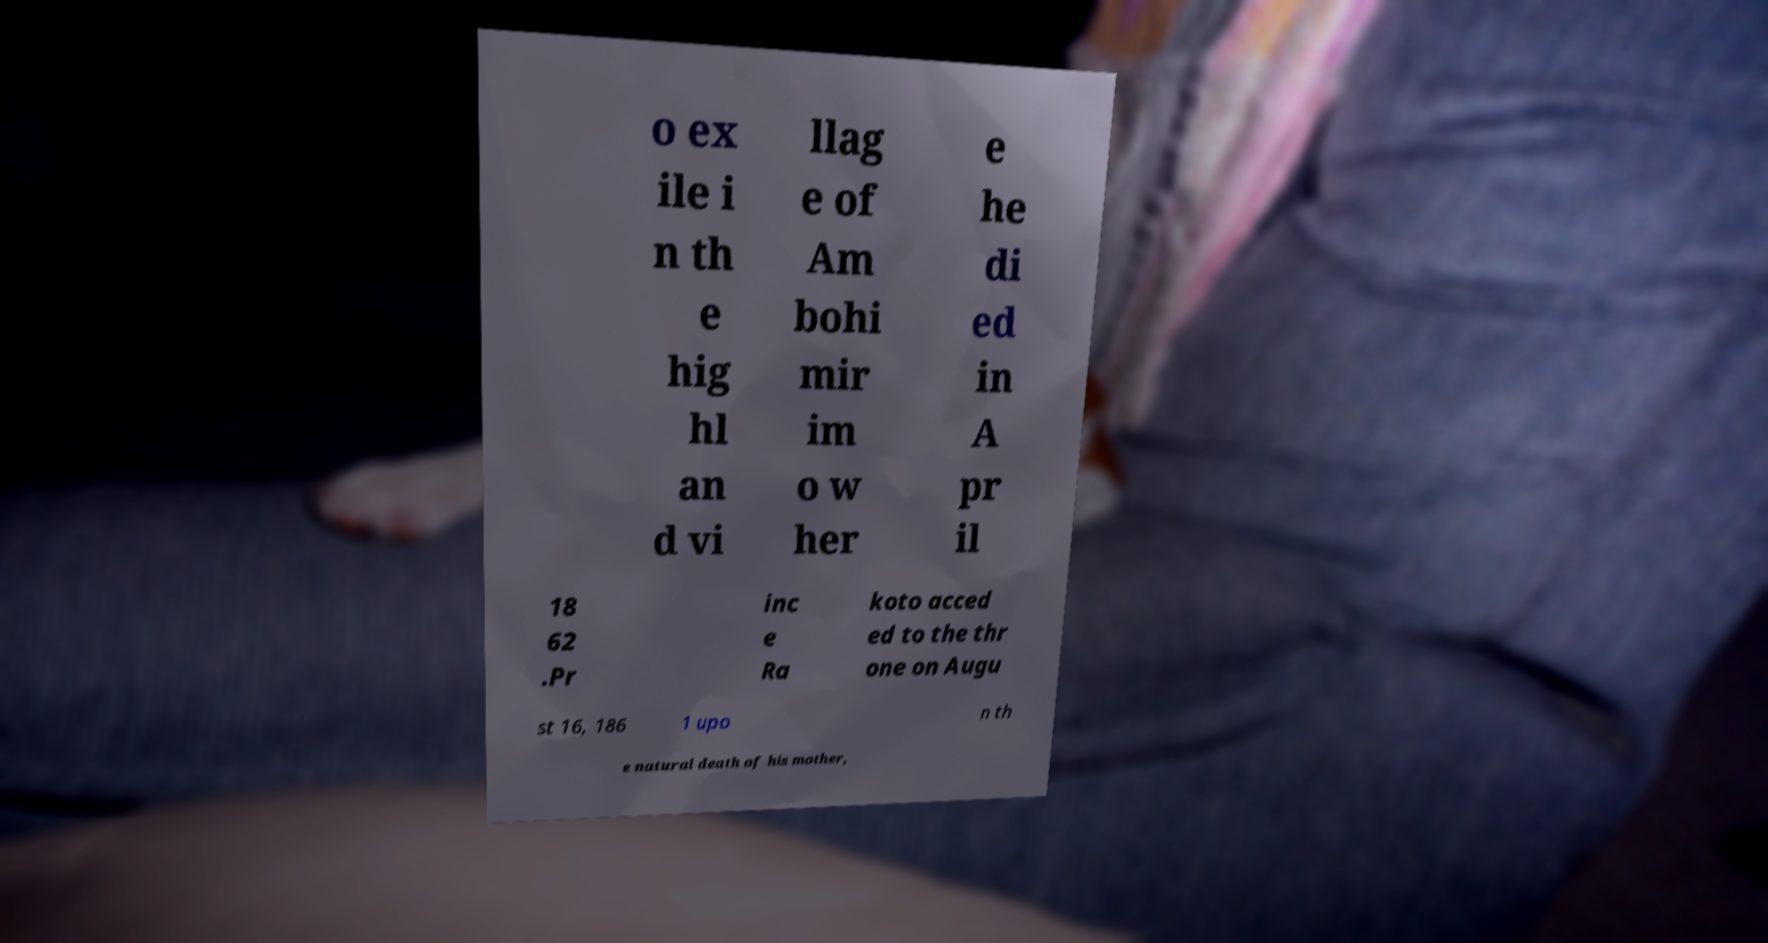Could you extract and type out the text from this image? o ex ile i n th e hig hl an d vi llag e of Am bohi mir im o w her e he di ed in A pr il 18 62 .Pr inc e Ra koto acced ed to the thr one on Augu st 16, 186 1 upo n th e natural death of his mother, 